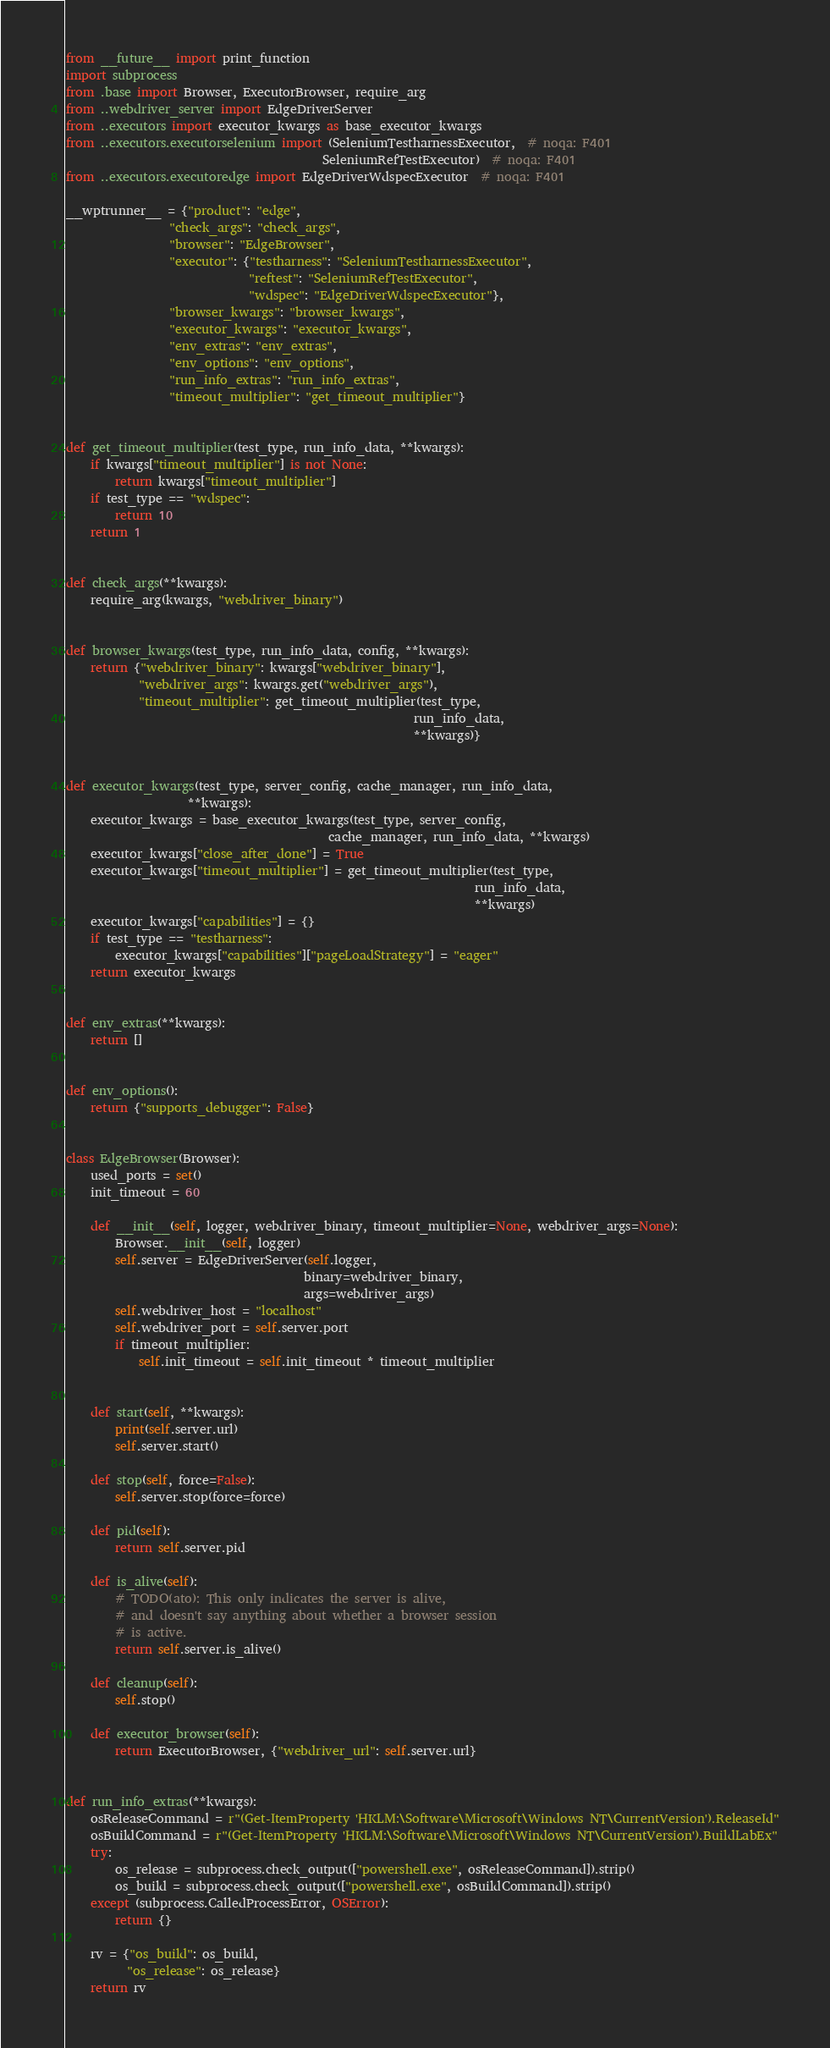Convert code to text. <code><loc_0><loc_0><loc_500><loc_500><_Python_>from __future__ import print_function
import subprocess
from .base import Browser, ExecutorBrowser, require_arg
from ..webdriver_server import EdgeDriverServer
from ..executors import executor_kwargs as base_executor_kwargs
from ..executors.executorselenium import (SeleniumTestharnessExecutor,  # noqa: F401
                                          SeleniumRefTestExecutor)  # noqa: F401
from ..executors.executoredge import EdgeDriverWdspecExecutor  # noqa: F401

__wptrunner__ = {"product": "edge",
                 "check_args": "check_args",
                 "browser": "EdgeBrowser",
                 "executor": {"testharness": "SeleniumTestharnessExecutor",
                              "reftest": "SeleniumRefTestExecutor",
                              "wdspec": "EdgeDriverWdspecExecutor"},
                 "browser_kwargs": "browser_kwargs",
                 "executor_kwargs": "executor_kwargs",
                 "env_extras": "env_extras",
                 "env_options": "env_options",
                 "run_info_extras": "run_info_extras",
                 "timeout_multiplier": "get_timeout_multiplier"}


def get_timeout_multiplier(test_type, run_info_data, **kwargs):
    if kwargs["timeout_multiplier"] is not None:
        return kwargs["timeout_multiplier"]
    if test_type == "wdspec":
        return 10
    return 1


def check_args(**kwargs):
    require_arg(kwargs, "webdriver_binary")


def browser_kwargs(test_type, run_info_data, config, **kwargs):
    return {"webdriver_binary": kwargs["webdriver_binary"],
            "webdriver_args": kwargs.get("webdriver_args"),
            "timeout_multiplier": get_timeout_multiplier(test_type,
                                                         run_info_data,
                                                         **kwargs)}


def executor_kwargs(test_type, server_config, cache_manager, run_info_data,
                    **kwargs):
    executor_kwargs = base_executor_kwargs(test_type, server_config,
                                           cache_manager, run_info_data, **kwargs)
    executor_kwargs["close_after_done"] = True
    executor_kwargs["timeout_multiplier"] = get_timeout_multiplier(test_type,
                                                                   run_info_data,
                                                                   **kwargs)
    executor_kwargs["capabilities"] = {}
    if test_type == "testharness":
        executor_kwargs["capabilities"]["pageLoadStrategy"] = "eager"
    return executor_kwargs


def env_extras(**kwargs):
    return []


def env_options():
    return {"supports_debugger": False}


class EdgeBrowser(Browser):
    used_ports = set()
    init_timeout = 60

    def __init__(self, logger, webdriver_binary, timeout_multiplier=None, webdriver_args=None):
        Browser.__init__(self, logger)
        self.server = EdgeDriverServer(self.logger,
                                       binary=webdriver_binary,
                                       args=webdriver_args)
        self.webdriver_host = "localhost"
        self.webdriver_port = self.server.port
        if timeout_multiplier:
            self.init_timeout = self.init_timeout * timeout_multiplier


    def start(self, **kwargs):
        print(self.server.url)
        self.server.start()

    def stop(self, force=False):
        self.server.stop(force=force)

    def pid(self):
        return self.server.pid

    def is_alive(self):
        # TODO(ato): This only indicates the server is alive,
        # and doesn't say anything about whether a browser session
        # is active.
        return self.server.is_alive()

    def cleanup(self):
        self.stop()

    def executor_browser(self):
        return ExecutorBrowser, {"webdriver_url": self.server.url}


def run_info_extras(**kwargs):
    osReleaseCommand = r"(Get-ItemProperty 'HKLM:\Software\Microsoft\Windows NT\CurrentVersion').ReleaseId"
    osBuildCommand = r"(Get-ItemProperty 'HKLM:\Software\Microsoft\Windows NT\CurrentVersion').BuildLabEx"
    try:
        os_release = subprocess.check_output(["powershell.exe", osReleaseCommand]).strip()
        os_build = subprocess.check_output(["powershell.exe", osBuildCommand]).strip()
    except (subprocess.CalledProcessError, OSError):
        return {}

    rv = {"os_build": os_build,
          "os_release": os_release}
    return rv
</code> 